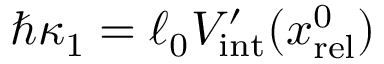Convert formula to latex. <formula><loc_0><loc_0><loc_500><loc_500>\hbar { \kappa } _ { 1 } = \ell _ { 0 } V _ { i n t } ^ { \prime } ( x _ { r e l } ^ { 0 } )</formula> 